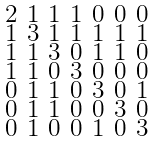Convert formula to latex. <formula><loc_0><loc_0><loc_500><loc_500>\begin{smallmatrix} 2 & 1 & 1 & 1 & 0 & 0 & 0 \\ 1 & 3 & 1 & 1 & 1 & 1 & 1 \\ 1 & 1 & 3 & 0 & 1 & 1 & 0 \\ 1 & 1 & 0 & 3 & 0 & 0 & 0 \\ 0 & 1 & 1 & 0 & 3 & 0 & 1 \\ 0 & 1 & 1 & 0 & 0 & 3 & 0 \\ 0 & 1 & 0 & 0 & 1 & 0 & 3 \end{smallmatrix}</formula> 